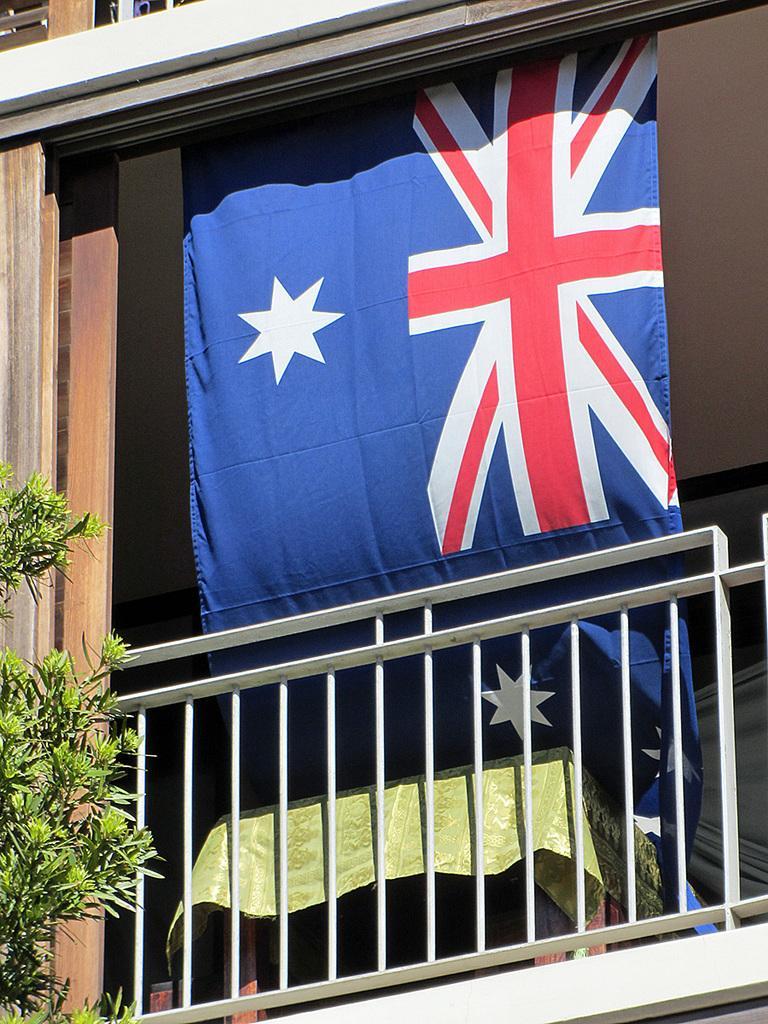How would you summarize this image in a sentence or two? In this picture I can see a flag, fence, tree and other objects. 